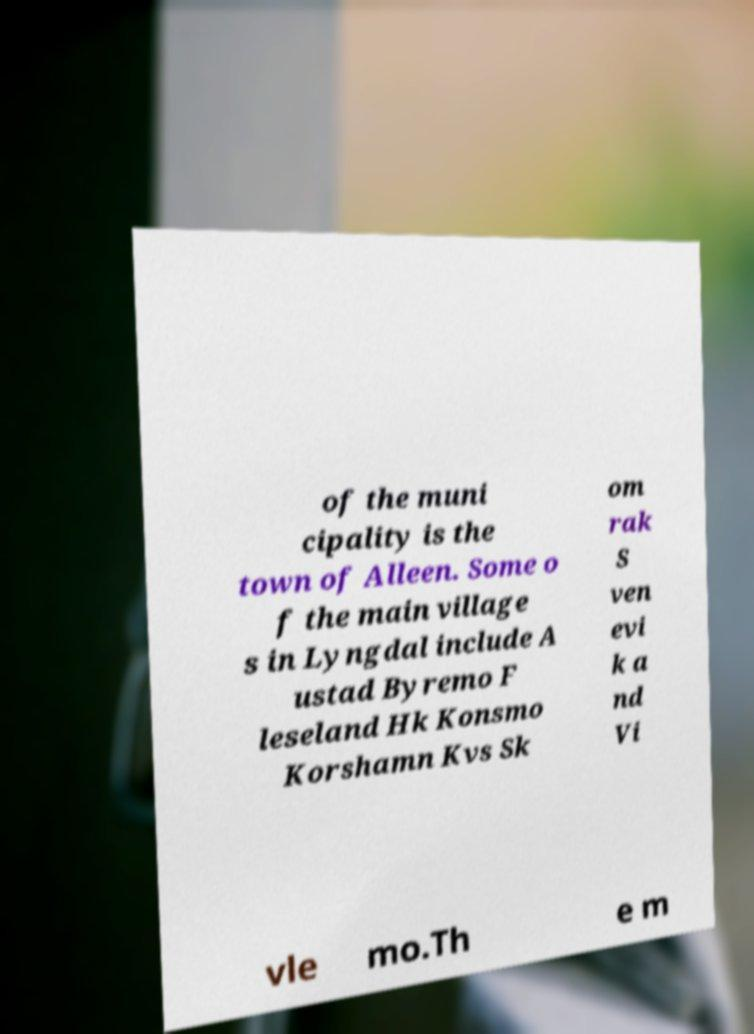For documentation purposes, I need the text within this image transcribed. Could you provide that? of the muni cipality is the town of Alleen. Some o f the main village s in Lyngdal include A ustad Byremo F leseland Hk Konsmo Korshamn Kvs Sk om rak S ven evi k a nd Vi vle mo.Th e m 